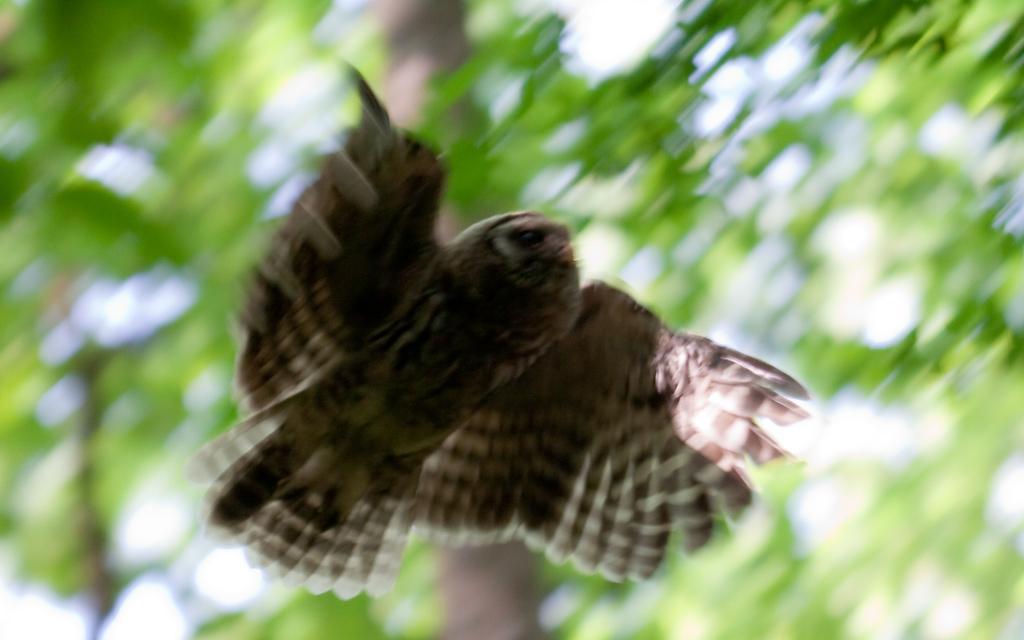Describe this image in one or two sentences. In this image we can see a bird flying. On the backside we can see some green plants. 